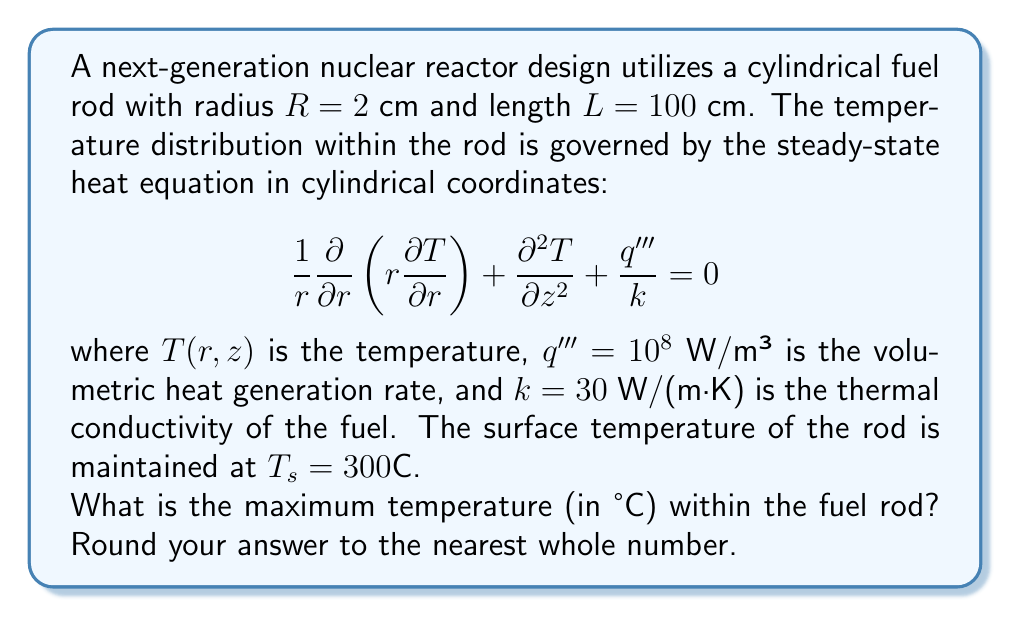Can you solve this math problem? To solve this problem, we'll follow these steps:

1) The temperature distribution in this case is symmetric about the z-axis and independent of z due to the uniform heat generation and boundary conditions. Therefore, the heat equation simplifies to:

   $$ \frac{1}{r} \frac{d}{dr}\left(r \frac{dT}{dr}\right) + \frac{q'''}{k} = 0 $$

2) Integrating this equation once with respect to r:

   $$ r \frac{dT}{dr} = -\frac{q'''}{2k}r^2 + C_1 $$

3) The temperature must be finite at r = 0, which implies C₁ = 0. So:

   $$ \frac{dT}{dr} = -\frac{q'''}{2k}r $$

4) Integrating again:

   $$ T(r) = -\frac{q'''}{4k}r^2 + C_2 $$

5) Apply the boundary condition T(R) = T_s:

   $$ T_s = -\frac{q'''}{4k}R^2 + C_2 $$

   $$ C_2 = T_s + \frac{q'''}{4k}R^2 $$

6) Therefore, the temperature distribution is:

   $$ T(r) = T_s + \frac{q'''}{4k}(R^2 - r^2) $$

7) The maximum temperature occurs at the center (r = 0):

   $$ T_{max} = T_s + \frac{q'''}{4k}R^2 $$

8) Substituting the given values:

   $$ T_{max} = 300 + \frac{10^8}{4 \cdot 30} \cdot (0.02)^2 $$

   $$ T_{max} = 300 + 333.33 = 633.33°C $$

9) Rounding to the nearest whole number:

   $$ T_{max} ≈ 633°C $$
Answer: 633°C 